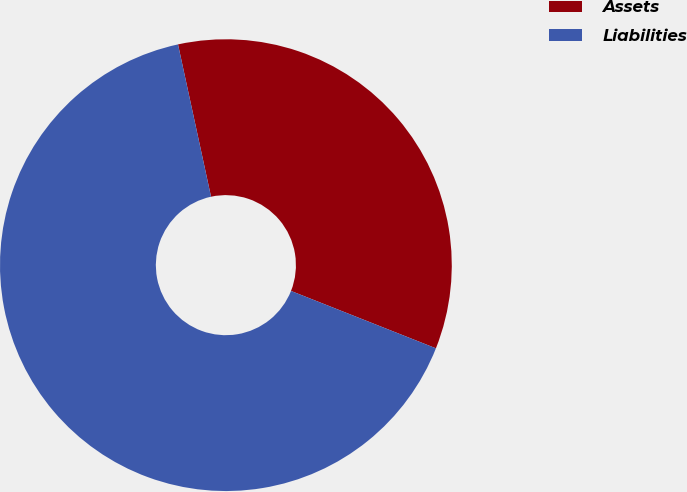<chart> <loc_0><loc_0><loc_500><loc_500><pie_chart><fcel>Assets<fcel>Liabilities<nl><fcel>34.4%<fcel>65.6%<nl></chart> 